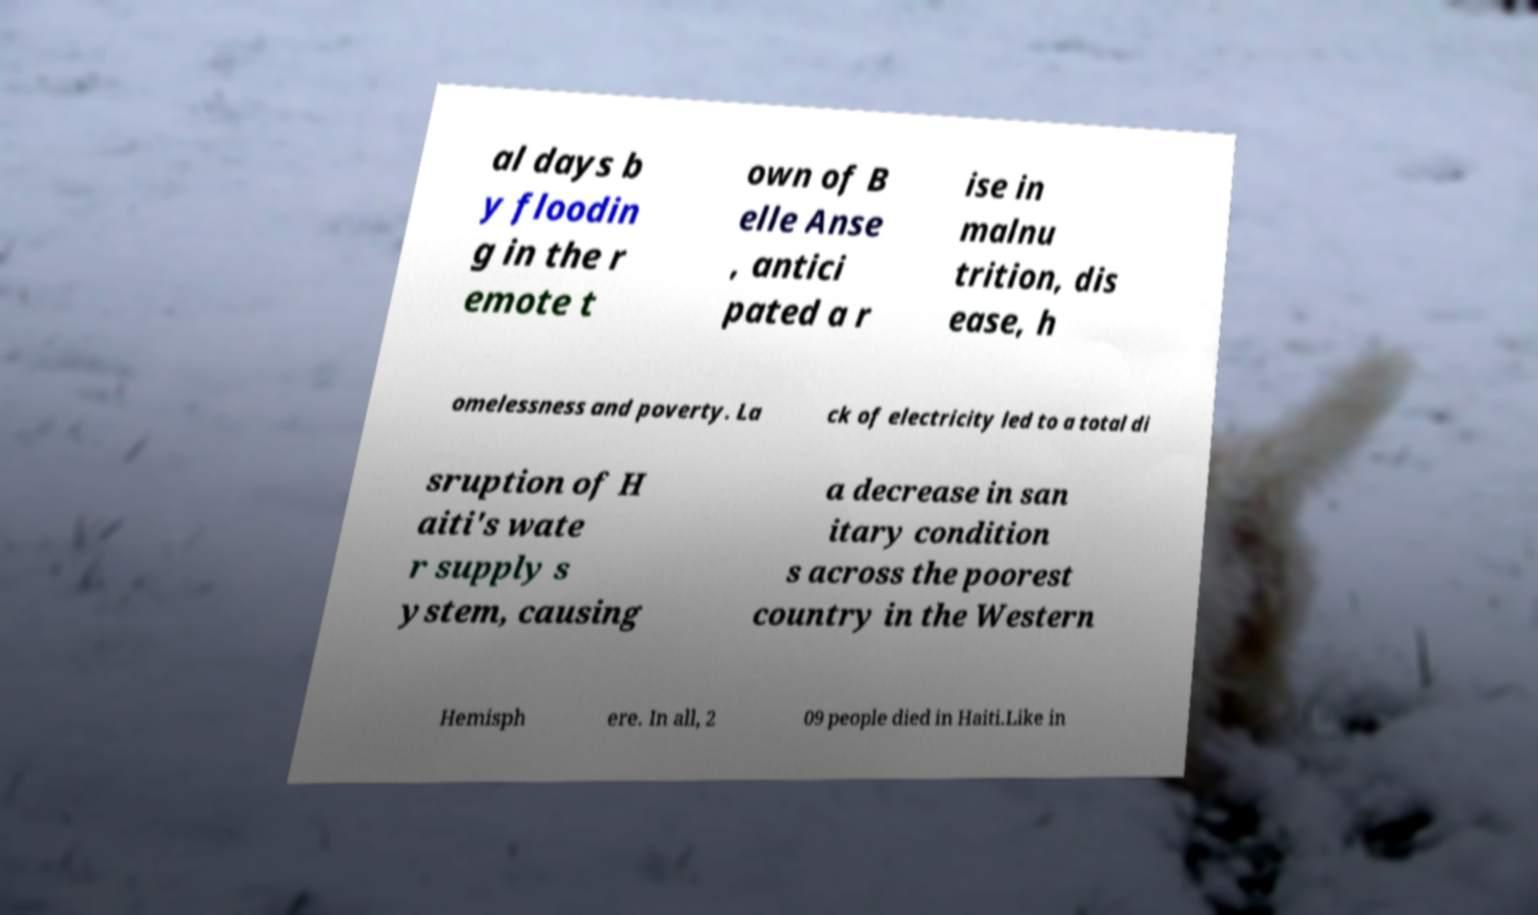Could you extract and type out the text from this image? al days b y floodin g in the r emote t own of B elle Anse , antici pated a r ise in malnu trition, dis ease, h omelessness and poverty. La ck of electricity led to a total di sruption of H aiti's wate r supply s ystem, causing a decrease in san itary condition s across the poorest country in the Western Hemisph ere. In all, 2 09 people died in Haiti.Like in 